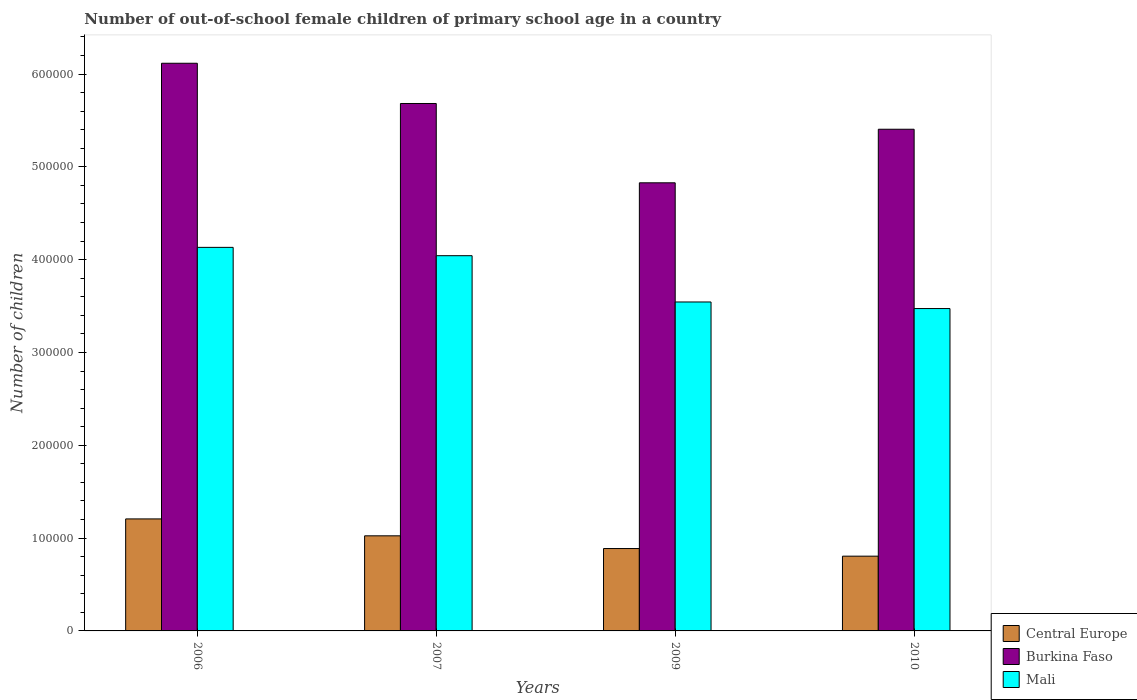How many different coloured bars are there?
Your answer should be very brief. 3. How many groups of bars are there?
Your response must be concise. 4. Are the number of bars per tick equal to the number of legend labels?
Ensure brevity in your answer.  Yes. Are the number of bars on each tick of the X-axis equal?
Keep it short and to the point. Yes. How many bars are there on the 2nd tick from the left?
Provide a succinct answer. 3. How many bars are there on the 4th tick from the right?
Provide a short and direct response. 3. What is the label of the 4th group of bars from the left?
Provide a succinct answer. 2010. In how many cases, is the number of bars for a given year not equal to the number of legend labels?
Your response must be concise. 0. What is the number of out-of-school female children in Central Europe in 2010?
Provide a short and direct response. 8.06e+04. Across all years, what is the maximum number of out-of-school female children in Burkina Faso?
Offer a very short reply. 6.12e+05. Across all years, what is the minimum number of out-of-school female children in Mali?
Offer a very short reply. 3.47e+05. In which year was the number of out-of-school female children in Burkina Faso maximum?
Your response must be concise. 2006. In which year was the number of out-of-school female children in Central Europe minimum?
Keep it short and to the point. 2010. What is the total number of out-of-school female children in Burkina Faso in the graph?
Ensure brevity in your answer.  2.20e+06. What is the difference between the number of out-of-school female children in Burkina Faso in 2006 and that in 2010?
Provide a succinct answer. 7.11e+04. What is the difference between the number of out-of-school female children in Mali in 2007 and the number of out-of-school female children in Burkina Faso in 2006?
Make the answer very short. -2.07e+05. What is the average number of out-of-school female children in Mali per year?
Keep it short and to the point. 3.80e+05. In the year 2006, what is the difference between the number of out-of-school female children in Burkina Faso and number of out-of-school female children in Mali?
Ensure brevity in your answer.  1.98e+05. In how many years, is the number of out-of-school female children in Mali greater than 160000?
Give a very brief answer. 4. What is the ratio of the number of out-of-school female children in Mali in 2006 to that in 2007?
Provide a short and direct response. 1.02. Is the difference between the number of out-of-school female children in Burkina Faso in 2009 and 2010 greater than the difference between the number of out-of-school female children in Mali in 2009 and 2010?
Provide a short and direct response. No. What is the difference between the highest and the second highest number of out-of-school female children in Central Europe?
Give a very brief answer. 1.82e+04. What is the difference between the highest and the lowest number of out-of-school female children in Burkina Faso?
Keep it short and to the point. 1.29e+05. Is the sum of the number of out-of-school female children in Central Europe in 2006 and 2010 greater than the maximum number of out-of-school female children in Burkina Faso across all years?
Provide a short and direct response. No. What does the 3rd bar from the left in 2007 represents?
Offer a very short reply. Mali. What does the 2nd bar from the right in 2006 represents?
Make the answer very short. Burkina Faso. Are the values on the major ticks of Y-axis written in scientific E-notation?
Provide a succinct answer. No. How many legend labels are there?
Provide a short and direct response. 3. What is the title of the graph?
Your answer should be very brief. Number of out-of-school female children of primary school age in a country. Does "Antigua and Barbuda" appear as one of the legend labels in the graph?
Provide a short and direct response. No. What is the label or title of the X-axis?
Provide a succinct answer. Years. What is the label or title of the Y-axis?
Give a very brief answer. Number of children. What is the Number of children in Central Europe in 2006?
Ensure brevity in your answer.  1.21e+05. What is the Number of children of Burkina Faso in 2006?
Your answer should be very brief. 6.12e+05. What is the Number of children of Mali in 2006?
Make the answer very short. 4.13e+05. What is the Number of children of Central Europe in 2007?
Your response must be concise. 1.02e+05. What is the Number of children in Burkina Faso in 2007?
Your answer should be compact. 5.68e+05. What is the Number of children of Mali in 2007?
Ensure brevity in your answer.  4.04e+05. What is the Number of children in Central Europe in 2009?
Make the answer very short. 8.88e+04. What is the Number of children in Burkina Faso in 2009?
Keep it short and to the point. 4.83e+05. What is the Number of children of Mali in 2009?
Give a very brief answer. 3.54e+05. What is the Number of children in Central Europe in 2010?
Your answer should be compact. 8.06e+04. What is the Number of children of Burkina Faso in 2010?
Your answer should be very brief. 5.41e+05. What is the Number of children in Mali in 2010?
Your response must be concise. 3.47e+05. Across all years, what is the maximum Number of children in Central Europe?
Offer a very short reply. 1.21e+05. Across all years, what is the maximum Number of children of Burkina Faso?
Your response must be concise. 6.12e+05. Across all years, what is the maximum Number of children in Mali?
Offer a very short reply. 4.13e+05. Across all years, what is the minimum Number of children of Central Europe?
Offer a terse response. 8.06e+04. Across all years, what is the minimum Number of children of Burkina Faso?
Your response must be concise. 4.83e+05. Across all years, what is the minimum Number of children of Mali?
Provide a short and direct response. 3.47e+05. What is the total Number of children in Central Europe in the graph?
Ensure brevity in your answer.  3.92e+05. What is the total Number of children of Burkina Faso in the graph?
Offer a very short reply. 2.20e+06. What is the total Number of children of Mali in the graph?
Offer a terse response. 1.52e+06. What is the difference between the Number of children in Central Europe in 2006 and that in 2007?
Ensure brevity in your answer.  1.82e+04. What is the difference between the Number of children of Burkina Faso in 2006 and that in 2007?
Your response must be concise. 4.33e+04. What is the difference between the Number of children in Mali in 2006 and that in 2007?
Your response must be concise. 8988. What is the difference between the Number of children in Central Europe in 2006 and that in 2009?
Keep it short and to the point. 3.19e+04. What is the difference between the Number of children of Burkina Faso in 2006 and that in 2009?
Keep it short and to the point. 1.29e+05. What is the difference between the Number of children in Mali in 2006 and that in 2009?
Provide a short and direct response. 5.88e+04. What is the difference between the Number of children in Central Europe in 2006 and that in 2010?
Offer a very short reply. 4.01e+04. What is the difference between the Number of children of Burkina Faso in 2006 and that in 2010?
Give a very brief answer. 7.11e+04. What is the difference between the Number of children in Mali in 2006 and that in 2010?
Offer a terse response. 6.59e+04. What is the difference between the Number of children in Central Europe in 2007 and that in 2009?
Keep it short and to the point. 1.37e+04. What is the difference between the Number of children of Burkina Faso in 2007 and that in 2009?
Ensure brevity in your answer.  8.55e+04. What is the difference between the Number of children in Mali in 2007 and that in 2009?
Keep it short and to the point. 4.99e+04. What is the difference between the Number of children of Central Europe in 2007 and that in 2010?
Offer a terse response. 2.19e+04. What is the difference between the Number of children of Burkina Faso in 2007 and that in 2010?
Provide a short and direct response. 2.77e+04. What is the difference between the Number of children in Mali in 2007 and that in 2010?
Your answer should be compact. 5.69e+04. What is the difference between the Number of children in Central Europe in 2009 and that in 2010?
Make the answer very short. 8214. What is the difference between the Number of children in Burkina Faso in 2009 and that in 2010?
Offer a terse response. -5.77e+04. What is the difference between the Number of children in Mali in 2009 and that in 2010?
Provide a short and direct response. 7084. What is the difference between the Number of children in Central Europe in 2006 and the Number of children in Burkina Faso in 2007?
Give a very brief answer. -4.48e+05. What is the difference between the Number of children in Central Europe in 2006 and the Number of children in Mali in 2007?
Your answer should be compact. -2.84e+05. What is the difference between the Number of children in Burkina Faso in 2006 and the Number of children in Mali in 2007?
Offer a very short reply. 2.07e+05. What is the difference between the Number of children in Central Europe in 2006 and the Number of children in Burkina Faso in 2009?
Provide a succinct answer. -3.62e+05. What is the difference between the Number of children in Central Europe in 2006 and the Number of children in Mali in 2009?
Keep it short and to the point. -2.34e+05. What is the difference between the Number of children of Burkina Faso in 2006 and the Number of children of Mali in 2009?
Offer a terse response. 2.57e+05. What is the difference between the Number of children in Central Europe in 2006 and the Number of children in Burkina Faso in 2010?
Your answer should be compact. -4.20e+05. What is the difference between the Number of children of Central Europe in 2006 and the Number of children of Mali in 2010?
Your answer should be compact. -2.27e+05. What is the difference between the Number of children of Burkina Faso in 2006 and the Number of children of Mali in 2010?
Provide a succinct answer. 2.64e+05. What is the difference between the Number of children of Central Europe in 2007 and the Number of children of Burkina Faso in 2009?
Provide a short and direct response. -3.80e+05. What is the difference between the Number of children in Central Europe in 2007 and the Number of children in Mali in 2009?
Provide a short and direct response. -2.52e+05. What is the difference between the Number of children of Burkina Faso in 2007 and the Number of children of Mali in 2009?
Your response must be concise. 2.14e+05. What is the difference between the Number of children of Central Europe in 2007 and the Number of children of Burkina Faso in 2010?
Provide a short and direct response. -4.38e+05. What is the difference between the Number of children in Central Europe in 2007 and the Number of children in Mali in 2010?
Make the answer very short. -2.45e+05. What is the difference between the Number of children of Burkina Faso in 2007 and the Number of children of Mali in 2010?
Give a very brief answer. 2.21e+05. What is the difference between the Number of children of Central Europe in 2009 and the Number of children of Burkina Faso in 2010?
Your answer should be compact. -4.52e+05. What is the difference between the Number of children of Central Europe in 2009 and the Number of children of Mali in 2010?
Provide a short and direct response. -2.59e+05. What is the difference between the Number of children of Burkina Faso in 2009 and the Number of children of Mali in 2010?
Give a very brief answer. 1.35e+05. What is the average Number of children of Central Europe per year?
Keep it short and to the point. 9.81e+04. What is the average Number of children of Burkina Faso per year?
Ensure brevity in your answer.  5.51e+05. What is the average Number of children of Mali per year?
Offer a very short reply. 3.80e+05. In the year 2006, what is the difference between the Number of children in Central Europe and Number of children in Burkina Faso?
Your response must be concise. -4.91e+05. In the year 2006, what is the difference between the Number of children in Central Europe and Number of children in Mali?
Offer a terse response. -2.93e+05. In the year 2006, what is the difference between the Number of children of Burkina Faso and Number of children of Mali?
Your response must be concise. 1.98e+05. In the year 2007, what is the difference between the Number of children in Central Europe and Number of children in Burkina Faso?
Your answer should be very brief. -4.66e+05. In the year 2007, what is the difference between the Number of children in Central Europe and Number of children in Mali?
Make the answer very short. -3.02e+05. In the year 2007, what is the difference between the Number of children of Burkina Faso and Number of children of Mali?
Make the answer very short. 1.64e+05. In the year 2009, what is the difference between the Number of children of Central Europe and Number of children of Burkina Faso?
Your answer should be very brief. -3.94e+05. In the year 2009, what is the difference between the Number of children of Central Europe and Number of children of Mali?
Offer a very short reply. -2.66e+05. In the year 2009, what is the difference between the Number of children of Burkina Faso and Number of children of Mali?
Your answer should be very brief. 1.28e+05. In the year 2010, what is the difference between the Number of children of Central Europe and Number of children of Burkina Faso?
Give a very brief answer. -4.60e+05. In the year 2010, what is the difference between the Number of children in Central Europe and Number of children in Mali?
Your answer should be compact. -2.67e+05. In the year 2010, what is the difference between the Number of children in Burkina Faso and Number of children in Mali?
Offer a terse response. 1.93e+05. What is the ratio of the Number of children of Central Europe in 2006 to that in 2007?
Give a very brief answer. 1.18. What is the ratio of the Number of children of Burkina Faso in 2006 to that in 2007?
Your response must be concise. 1.08. What is the ratio of the Number of children in Mali in 2006 to that in 2007?
Ensure brevity in your answer.  1.02. What is the ratio of the Number of children in Central Europe in 2006 to that in 2009?
Provide a short and direct response. 1.36. What is the ratio of the Number of children of Burkina Faso in 2006 to that in 2009?
Offer a very short reply. 1.27. What is the ratio of the Number of children of Mali in 2006 to that in 2009?
Provide a short and direct response. 1.17. What is the ratio of the Number of children in Central Europe in 2006 to that in 2010?
Offer a terse response. 1.5. What is the ratio of the Number of children in Burkina Faso in 2006 to that in 2010?
Your response must be concise. 1.13. What is the ratio of the Number of children of Mali in 2006 to that in 2010?
Offer a terse response. 1.19. What is the ratio of the Number of children in Central Europe in 2007 to that in 2009?
Provide a succinct answer. 1.15. What is the ratio of the Number of children of Burkina Faso in 2007 to that in 2009?
Keep it short and to the point. 1.18. What is the ratio of the Number of children of Mali in 2007 to that in 2009?
Offer a very short reply. 1.14. What is the ratio of the Number of children in Central Europe in 2007 to that in 2010?
Keep it short and to the point. 1.27. What is the ratio of the Number of children of Burkina Faso in 2007 to that in 2010?
Make the answer very short. 1.05. What is the ratio of the Number of children of Mali in 2007 to that in 2010?
Make the answer very short. 1.16. What is the ratio of the Number of children of Central Europe in 2009 to that in 2010?
Your response must be concise. 1.1. What is the ratio of the Number of children of Burkina Faso in 2009 to that in 2010?
Ensure brevity in your answer.  0.89. What is the ratio of the Number of children in Mali in 2009 to that in 2010?
Your answer should be compact. 1.02. What is the difference between the highest and the second highest Number of children in Central Europe?
Keep it short and to the point. 1.82e+04. What is the difference between the highest and the second highest Number of children of Burkina Faso?
Make the answer very short. 4.33e+04. What is the difference between the highest and the second highest Number of children in Mali?
Provide a succinct answer. 8988. What is the difference between the highest and the lowest Number of children of Central Europe?
Ensure brevity in your answer.  4.01e+04. What is the difference between the highest and the lowest Number of children of Burkina Faso?
Give a very brief answer. 1.29e+05. What is the difference between the highest and the lowest Number of children of Mali?
Offer a very short reply. 6.59e+04. 